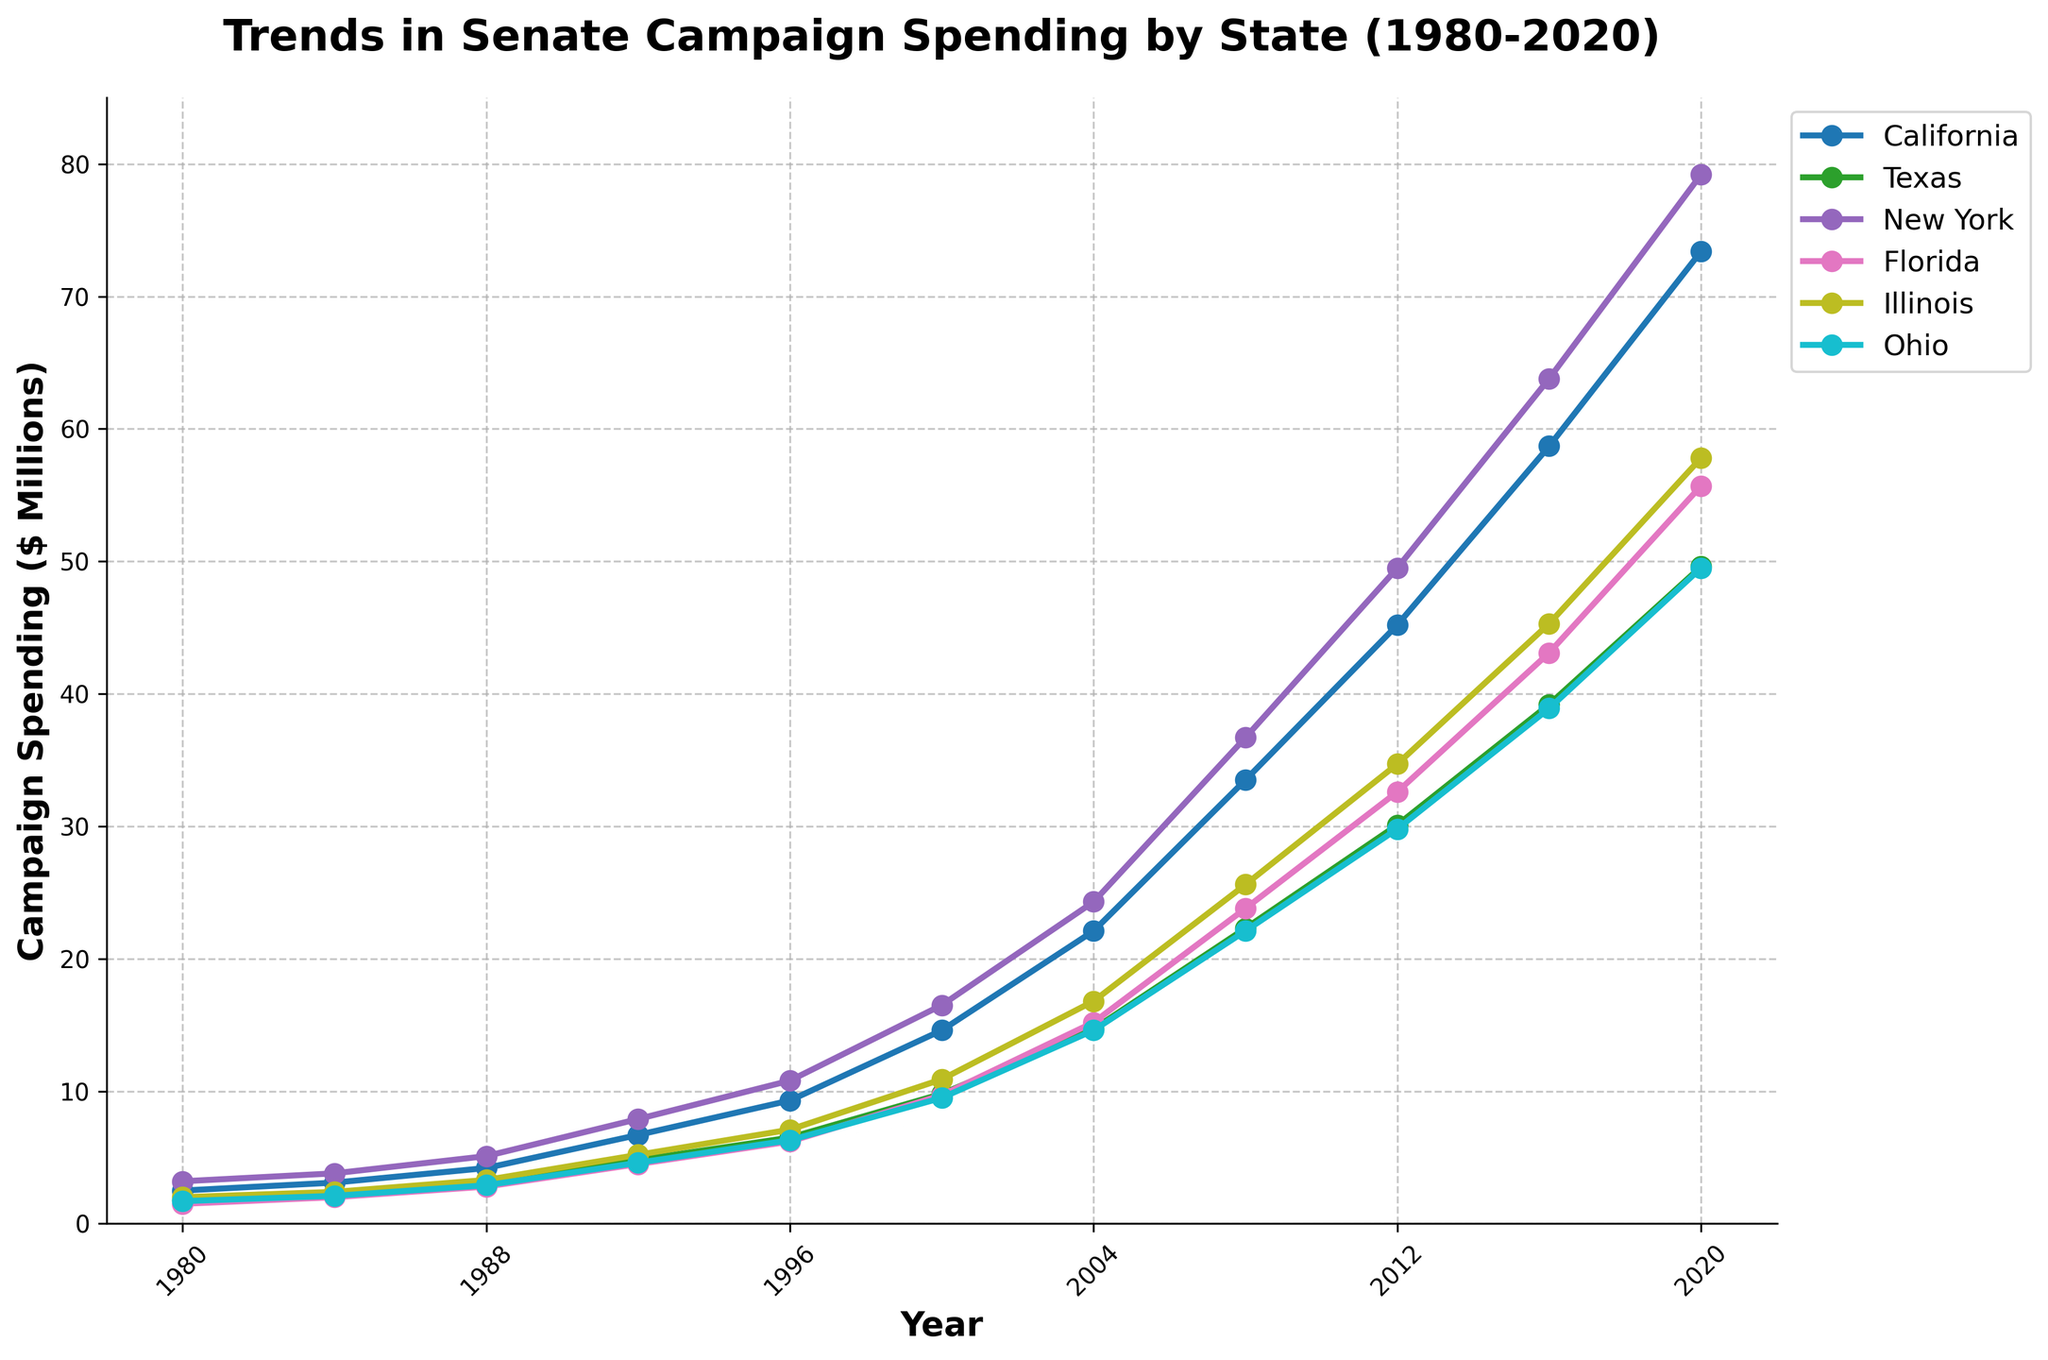When did California's campaign spending surpass $50 million? California's campaign spending is plotted in the graph. By looking at the points, it is clear from the trend that spending crossed $50 million between 2012 and 2016.
Answer: 2016 Which state had the highest campaign spending in 2008? The graph shows different lines for each state, and by locating the 2008 point on each line, the highest value is for New York.
Answer: New York By how much did Florida's campaign spending increase from 2004 to 2020? Locate Florida's values for 2004 ($15.2 million) and 2020 ($55.7 million). Subtract the 2004 value from the 2020 value: $55.7 million - $15.2 million = $40.5 million.
Answer: $40.5 million Which state experienced the largest increase in campaign spending from 1980 to 2020? By subtracting the spending values for each state in 1980 from their respective values in 2020 and comparing the differences, New York's increase ($79.2 million - $3.2 million = $76 million) is the largest.
Answer: New York What's the average campaign spending across all states in 1992? Sum the 1992 values for all states and divide by the number of states: (6.7 + 4.8 + 7.9 + 4.5 + 5.2 + 4.6) / 6 = 5.95 million.
Answer: $5.95 million How many times higher was Texas' campaign spending in 2020 compared to 1980? Divide Texas' 2020 spending by its 1980 spending: $49.6 million / $1.8 million ≈ 27.56 times higher.
Answer: ~27.56 times Which state had a relatively constant increase in campaign spending over the years? By observing the trends of each state, Texas reflects a relatively constant increase from the smoothness and consistent slope in the line.
Answer: Texas Is there a year where all states saw their campaign spending increase compared to the previous plotted year? By checking year-to-year increases for each state, every state shows an increase from 2016 to 2020.
Answer: Yes, 2016 to 2020 What is the approximate total campaign spending for all states combined in 2020? Sum the 2020 values for all states: $73.4 million + $49.6 million + $79.2 million + $55.7 million + $57.8 million + $49.5 million = $365.2 million.
Answer: $365.2 million 